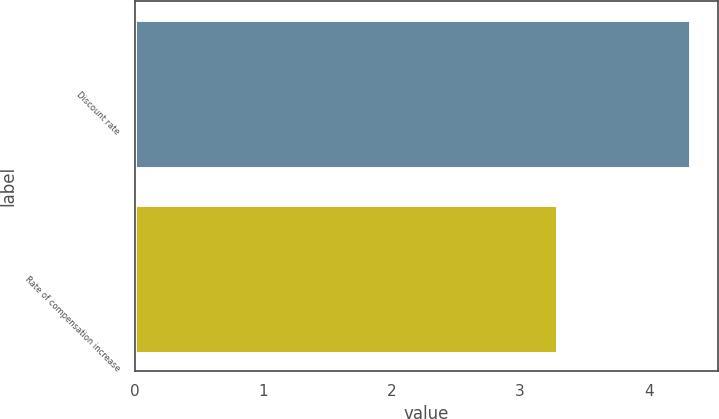Convert chart. <chart><loc_0><loc_0><loc_500><loc_500><bar_chart><fcel>Discount rate<fcel>Rate of compensation increase<nl><fcel>4.32<fcel>3.29<nl></chart> 